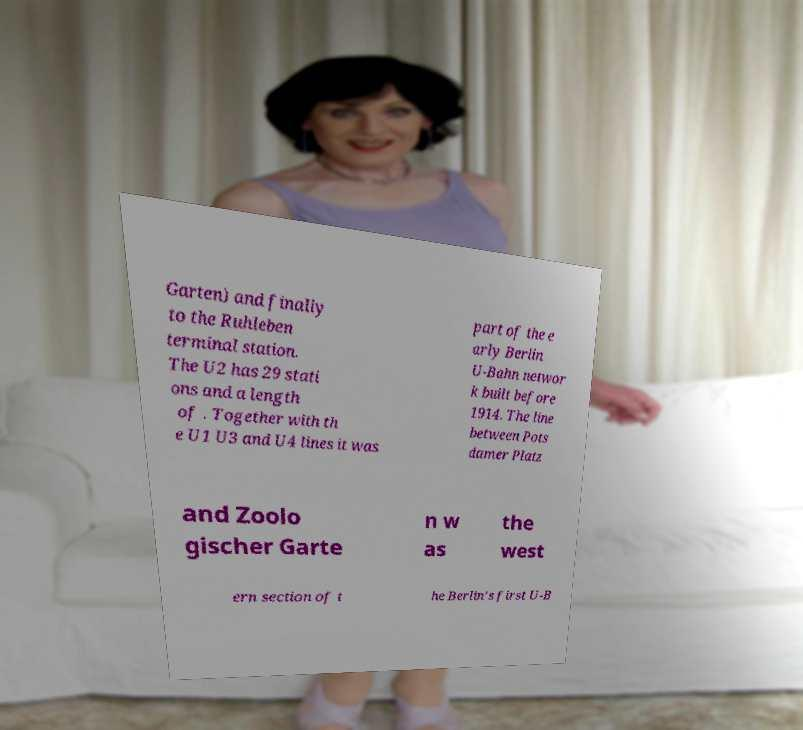What messages or text are displayed in this image? I need them in a readable, typed format. Garten) and finally to the Ruhleben terminal station. The U2 has 29 stati ons and a length of . Together with th e U1 U3 and U4 lines it was part of the e arly Berlin U-Bahn networ k built before 1914. The line between Pots damer Platz and Zoolo gischer Garte n w as the west ern section of t he Berlin's first U-B 